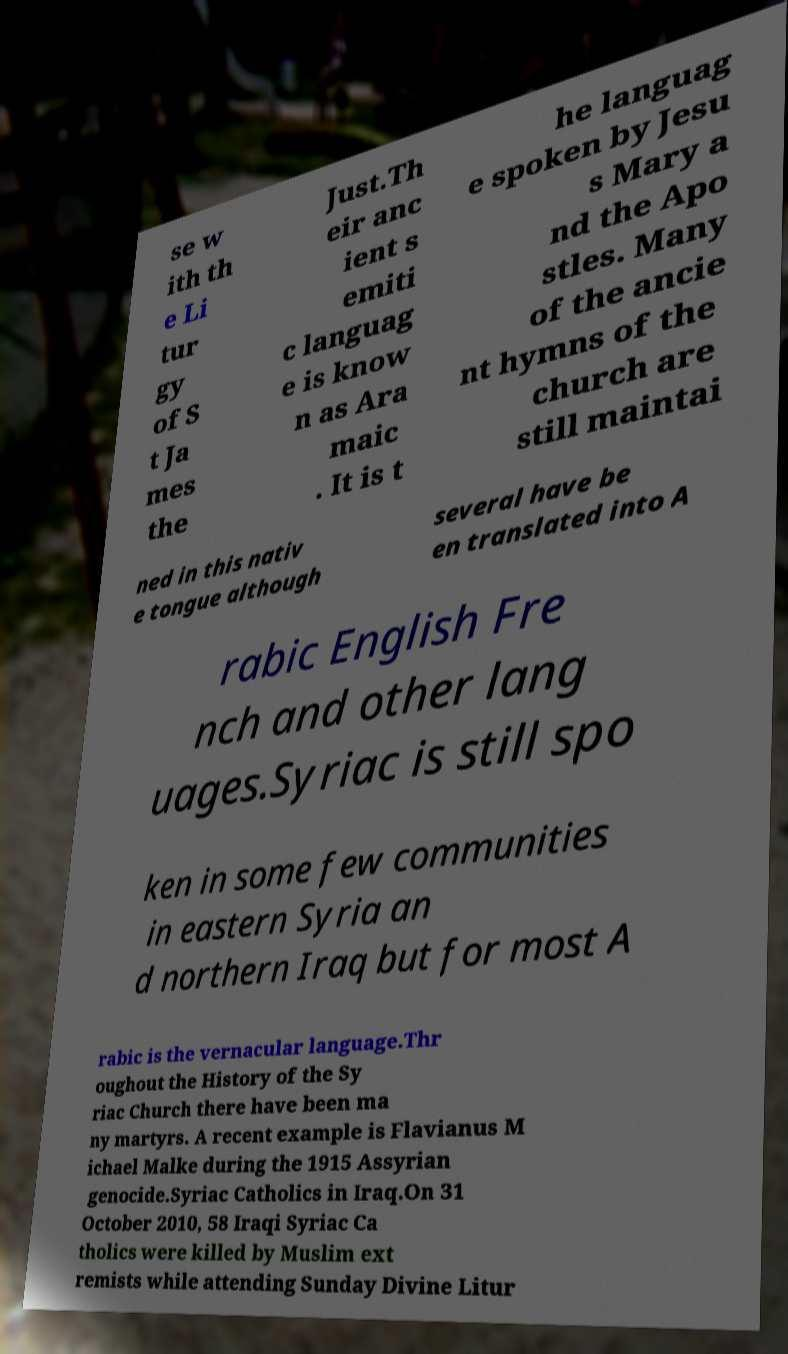For documentation purposes, I need the text within this image transcribed. Could you provide that? se w ith th e Li tur gy of S t Ja mes the Just.Th eir anc ient s emiti c languag e is know n as Ara maic . It is t he languag e spoken by Jesu s Mary a nd the Apo stles. Many of the ancie nt hymns of the church are still maintai ned in this nativ e tongue although several have be en translated into A rabic English Fre nch and other lang uages.Syriac is still spo ken in some few communities in eastern Syria an d northern Iraq but for most A rabic is the vernacular language.Thr oughout the History of the Sy riac Church there have been ma ny martyrs. A recent example is Flavianus M ichael Malke during the 1915 Assyrian genocide.Syriac Catholics in Iraq.On 31 October 2010, 58 Iraqi Syriac Ca tholics were killed by Muslim ext remists while attending Sunday Divine Litur 